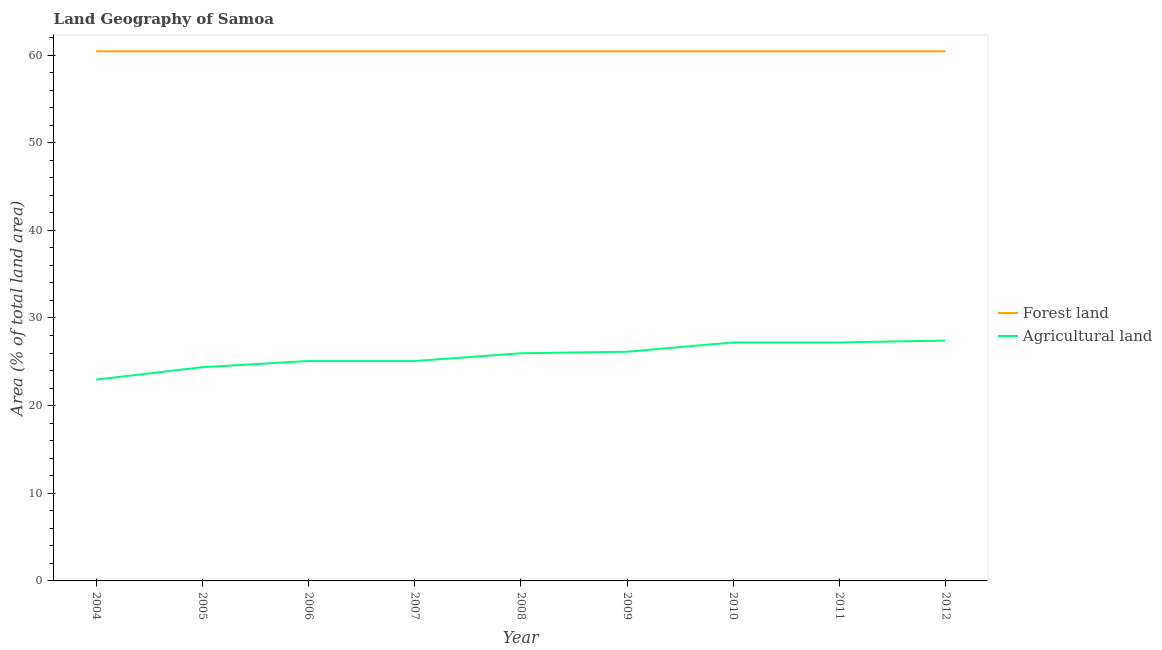How many different coloured lines are there?
Keep it short and to the point. 2. Is the number of lines equal to the number of legend labels?
Offer a terse response. Yes. What is the percentage of land area under agriculture in 2006?
Make the answer very short. 25.09. Across all years, what is the maximum percentage of land area under agriculture?
Offer a very short reply. 27.42. Across all years, what is the minimum percentage of land area under forests?
Offer a very short reply. 60.42. In which year was the percentage of land area under agriculture maximum?
Keep it short and to the point. 2012. What is the total percentage of land area under agriculture in the graph?
Provide a succinct answer. 231.48. What is the difference between the percentage of land area under forests in 2007 and that in 2008?
Ensure brevity in your answer.  0. What is the difference between the percentage of land area under agriculture in 2004 and the percentage of land area under forests in 2012?
Keep it short and to the point. -37.46. What is the average percentage of land area under forests per year?
Offer a terse response. 60.42. In the year 2009, what is the difference between the percentage of land area under agriculture and percentage of land area under forests?
Ensure brevity in your answer.  -34.28. What is the difference between the highest and the second highest percentage of land area under agriculture?
Your answer should be compact. 0.21. What is the difference between the highest and the lowest percentage of land area under agriculture?
Keep it short and to the point. 4.45. Is the sum of the percentage of land area under forests in 2007 and 2009 greater than the maximum percentage of land area under agriculture across all years?
Provide a short and direct response. Yes. Does the percentage of land area under forests monotonically increase over the years?
Provide a succinct answer. No. Is the percentage of land area under forests strictly greater than the percentage of land area under agriculture over the years?
Ensure brevity in your answer.  Yes. Is the percentage of land area under forests strictly less than the percentage of land area under agriculture over the years?
Offer a terse response. No. How many years are there in the graph?
Keep it short and to the point. 9. How are the legend labels stacked?
Give a very brief answer. Vertical. What is the title of the graph?
Your response must be concise. Land Geography of Samoa. What is the label or title of the X-axis?
Ensure brevity in your answer.  Year. What is the label or title of the Y-axis?
Provide a short and direct response. Area (% of total land area). What is the Area (% of total land area) of Forest land in 2004?
Keep it short and to the point. 60.42. What is the Area (% of total land area) in Agricultural land in 2004?
Provide a short and direct response. 22.97. What is the Area (% of total land area) of Forest land in 2005?
Your answer should be compact. 60.42. What is the Area (% of total land area) of Agricultural land in 2005?
Provide a short and direct response. 24.38. What is the Area (% of total land area) of Forest land in 2006?
Your response must be concise. 60.42. What is the Area (% of total land area) of Agricultural land in 2006?
Give a very brief answer. 25.09. What is the Area (% of total land area) of Forest land in 2007?
Make the answer very short. 60.42. What is the Area (% of total land area) in Agricultural land in 2007?
Give a very brief answer. 25.09. What is the Area (% of total land area) of Forest land in 2008?
Give a very brief answer. 60.42. What is the Area (% of total land area) of Agricultural land in 2008?
Provide a succinct answer. 25.97. What is the Area (% of total land area) in Forest land in 2009?
Your answer should be compact. 60.42. What is the Area (% of total land area) of Agricultural land in 2009?
Keep it short and to the point. 26.15. What is the Area (% of total land area) in Forest land in 2010?
Offer a terse response. 60.42. What is the Area (% of total land area) of Agricultural land in 2010?
Keep it short and to the point. 27.21. What is the Area (% of total land area) of Forest land in 2011?
Provide a succinct answer. 60.42. What is the Area (% of total land area) in Agricultural land in 2011?
Make the answer very short. 27.21. What is the Area (% of total land area) of Forest land in 2012?
Your answer should be compact. 60.42. What is the Area (% of total land area) of Agricultural land in 2012?
Provide a short and direct response. 27.42. Across all years, what is the maximum Area (% of total land area) of Forest land?
Keep it short and to the point. 60.42. Across all years, what is the maximum Area (% of total land area) in Agricultural land?
Make the answer very short. 27.42. Across all years, what is the minimum Area (% of total land area) of Forest land?
Your answer should be very brief. 60.42. Across all years, what is the minimum Area (% of total land area) in Agricultural land?
Keep it short and to the point. 22.97. What is the total Area (% of total land area) in Forest land in the graph?
Your answer should be compact. 543.82. What is the total Area (% of total land area) of Agricultural land in the graph?
Ensure brevity in your answer.  231.48. What is the difference between the Area (% of total land area) of Forest land in 2004 and that in 2005?
Provide a succinct answer. 0. What is the difference between the Area (% of total land area) of Agricultural land in 2004 and that in 2005?
Your answer should be very brief. -1.41. What is the difference between the Area (% of total land area) in Agricultural land in 2004 and that in 2006?
Keep it short and to the point. -2.12. What is the difference between the Area (% of total land area) in Agricultural land in 2004 and that in 2007?
Ensure brevity in your answer.  -2.12. What is the difference between the Area (% of total land area) of Agricultural land in 2004 and that in 2008?
Provide a short and direct response. -3. What is the difference between the Area (% of total land area) in Agricultural land in 2004 and that in 2009?
Your answer should be compact. -3.18. What is the difference between the Area (% of total land area) of Agricultural land in 2004 and that in 2010?
Offer a very short reply. -4.24. What is the difference between the Area (% of total land area) in Forest land in 2004 and that in 2011?
Give a very brief answer. 0. What is the difference between the Area (% of total land area) in Agricultural land in 2004 and that in 2011?
Your answer should be very brief. -4.24. What is the difference between the Area (% of total land area) of Forest land in 2004 and that in 2012?
Your answer should be compact. 0. What is the difference between the Area (% of total land area) of Agricultural land in 2004 and that in 2012?
Your answer should be compact. -4.45. What is the difference between the Area (% of total land area) of Agricultural land in 2005 and that in 2006?
Provide a short and direct response. -0.71. What is the difference between the Area (% of total land area) of Forest land in 2005 and that in 2007?
Your response must be concise. 0. What is the difference between the Area (% of total land area) in Agricultural land in 2005 and that in 2007?
Keep it short and to the point. -0.71. What is the difference between the Area (% of total land area) of Forest land in 2005 and that in 2008?
Ensure brevity in your answer.  0. What is the difference between the Area (% of total land area) of Agricultural land in 2005 and that in 2008?
Offer a very short reply. -1.59. What is the difference between the Area (% of total land area) in Forest land in 2005 and that in 2009?
Make the answer very short. 0. What is the difference between the Area (% of total land area) in Agricultural land in 2005 and that in 2009?
Offer a very short reply. -1.77. What is the difference between the Area (% of total land area) of Forest land in 2005 and that in 2010?
Your response must be concise. 0. What is the difference between the Area (% of total land area) in Agricultural land in 2005 and that in 2010?
Provide a short and direct response. -2.83. What is the difference between the Area (% of total land area) of Forest land in 2005 and that in 2011?
Your answer should be compact. 0. What is the difference between the Area (% of total land area) in Agricultural land in 2005 and that in 2011?
Your answer should be very brief. -2.83. What is the difference between the Area (% of total land area) in Forest land in 2005 and that in 2012?
Ensure brevity in your answer.  0. What is the difference between the Area (% of total land area) in Agricultural land in 2005 and that in 2012?
Provide a succinct answer. -3.04. What is the difference between the Area (% of total land area) of Forest land in 2006 and that in 2007?
Provide a short and direct response. 0. What is the difference between the Area (% of total land area) in Forest land in 2006 and that in 2008?
Offer a very short reply. 0. What is the difference between the Area (% of total land area) in Agricultural land in 2006 and that in 2008?
Make the answer very short. -0.88. What is the difference between the Area (% of total land area) in Agricultural land in 2006 and that in 2009?
Offer a very short reply. -1.06. What is the difference between the Area (% of total land area) in Agricultural land in 2006 and that in 2010?
Keep it short and to the point. -2.12. What is the difference between the Area (% of total land area) of Forest land in 2006 and that in 2011?
Your answer should be compact. 0. What is the difference between the Area (% of total land area) in Agricultural land in 2006 and that in 2011?
Your answer should be compact. -2.12. What is the difference between the Area (% of total land area) of Agricultural land in 2006 and that in 2012?
Your answer should be compact. -2.33. What is the difference between the Area (% of total land area) in Forest land in 2007 and that in 2008?
Ensure brevity in your answer.  0. What is the difference between the Area (% of total land area) in Agricultural land in 2007 and that in 2008?
Your answer should be very brief. -0.88. What is the difference between the Area (% of total land area) in Agricultural land in 2007 and that in 2009?
Your response must be concise. -1.06. What is the difference between the Area (% of total land area) in Agricultural land in 2007 and that in 2010?
Keep it short and to the point. -2.12. What is the difference between the Area (% of total land area) of Forest land in 2007 and that in 2011?
Your response must be concise. 0. What is the difference between the Area (% of total land area) of Agricultural land in 2007 and that in 2011?
Keep it short and to the point. -2.12. What is the difference between the Area (% of total land area) in Forest land in 2007 and that in 2012?
Provide a short and direct response. 0. What is the difference between the Area (% of total land area) in Agricultural land in 2007 and that in 2012?
Keep it short and to the point. -2.33. What is the difference between the Area (% of total land area) of Agricultural land in 2008 and that in 2009?
Keep it short and to the point. -0.18. What is the difference between the Area (% of total land area) in Agricultural land in 2008 and that in 2010?
Give a very brief answer. -1.24. What is the difference between the Area (% of total land area) of Agricultural land in 2008 and that in 2011?
Provide a short and direct response. -1.24. What is the difference between the Area (% of total land area) of Agricultural land in 2008 and that in 2012?
Offer a very short reply. -1.45. What is the difference between the Area (% of total land area) in Agricultural land in 2009 and that in 2010?
Your answer should be compact. -1.06. What is the difference between the Area (% of total land area) in Agricultural land in 2009 and that in 2011?
Your answer should be very brief. -1.06. What is the difference between the Area (% of total land area) in Forest land in 2009 and that in 2012?
Your answer should be compact. 0. What is the difference between the Area (% of total land area) in Agricultural land in 2009 and that in 2012?
Offer a terse response. -1.27. What is the difference between the Area (% of total land area) of Forest land in 2010 and that in 2011?
Keep it short and to the point. 0. What is the difference between the Area (% of total land area) of Agricultural land in 2010 and that in 2011?
Make the answer very short. 0. What is the difference between the Area (% of total land area) in Forest land in 2010 and that in 2012?
Give a very brief answer. 0. What is the difference between the Area (% of total land area) of Agricultural land in 2010 and that in 2012?
Provide a succinct answer. -0.21. What is the difference between the Area (% of total land area) of Forest land in 2011 and that in 2012?
Make the answer very short. 0. What is the difference between the Area (% of total land area) of Agricultural land in 2011 and that in 2012?
Provide a short and direct response. -0.21. What is the difference between the Area (% of total land area) in Forest land in 2004 and the Area (% of total land area) in Agricultural land in 2005?
Make the answer very short. 36.04. What is the difference between the Area (% of total land area) in Forest land in 2004 and the Area (% of total land area) in Agricultural land in 2006?
Offer a very short reply. 35.34. What is the difference between the Area (% of total land area) of Forest land in 2004 and the Area (% of total land area) of Agricultural land in 2007?
Make the answer very short. 35.34. What is the difference between the Area (% of total land area) of Forest land in 2004 and the Area (% of total land area) of Agricultural land in 2008?
Keep it short and to the point. 34.45. What is the difference between the Area (% of total land area) in Forest land in 2004 and the Area (% of total land area) in Agricultural land in 2009?
Your answer should be very brief. 34.28. What is the difference between the Area (% of total land area) in Forest land in 2004 and the Area (% of total land area) in Agricultural land in 2010?
Offer a very short reply. 33.22. What is the difference between the Area (% of total land area) of Forest land in 2004 and the Area (% of total land area) of Agricultural land in 2011?
Make the answer very short. 33.22. What is the difference between the Area (% of total land area) in Forest land in 2004 and the Area (% of total land area) in Agricultural land in 2012?
Your response must be concise. 33. What is the difference between the Area (% of total land area) in Forest land in 2005 and the Area (% of total land area) in Agricultural land in 2006?
Your response must be concise. 35.34. What is the difference between the Area (% of total land area) in Forest land in 2005 and the Area (% of total land area) in Agricultural land in 2007?
Your answer should be very brief. 35.34. What is the difference between the Area (% of total land area) of Forest land in 2005 and the Area (% of total land area) of Agricultural land in 2008?
Your answer should be compact. 34.45. What is the difference between the Area (% of total land area) in Forest land in 2005 and the Area (% of total land area) in Agricultural land in 2009?
Ensure brevity in your answer.  34.28. What is the difference between the Area (% of total land area) in Forest land in 2005 and the Area (% of total land area) in Agricultural land in 2010?
Make the answer very short. 33.22. What is the difference between the Area (% of total land area) in Forest land in 2005 and the Area (% of total land area) in Agricultural land in 2011?
Keep it short and to the point. 33.22. What is the difference between the Area (% of total land area) in Forest land in 2005 and the Area (% of total land area) in Agricultural land in 2012?
Make the answer very short. 33. What is the difference between the Area (% of total land area) of Forest land in 2006 and the Area (% of total land area) of Agricultural land in 2007?
Give a very brief answer. 35.34. What is the difference between the Area (% of total land area) of Forest land in 2006 and the Area (% of total land area) of Agricultural land in 2008?
Offer a very short reply. 34.45. What is the difference between the Area (% of total land area) in Forest land in 2006 and the Area (% of total land area) in Agricultural land in 2009?
Provide a short and direct response. 34.28. What is the difference between the Area (% of total land area) of Forest land in 2006 and the Area (% of total land area) of Agricultural land in 2010?
Make the answer very short. 33.22. What is the difference between the Area (% of total land area) of Forest land in 2006 and the Area (% of total land area) of Agricultural land in 2011?
Provide a succinct answer. 33.22. What is the difference between the Area (% of total land area) of Forest land in 2006 and the Area (% of total land area) of Agricultural land in 2012?
Ensure brevity in your answer.  33. What is the difference between the Area (% of total land area) in Forest land in 2007 and the Area (% of total land area) in Agricultural land in 2008?
Ensure brevity in your answer.  34.45. What is the difference between the Area (% of total land area) of Forest land in 2007 and the Area (% of total land area) of Agricultural land in 2009?
Offer a very short reply. 34.28. What is the difference between the Area (% of total land area) of Forest land in 2007 and the Area (% of total land area) of Agricultural land in 2010?
Your response must be concise. 33.22. What is the difference between the Area (% of total land area) in Forest land in 2007 and the Area (% of total land area) in Agricultural land in 2011?
Your response must be concise. 33.22. What is the difference between the Area (% of total land area) in Forest land in 2007 and the Area (% of total land area) in Agricultural land in 2012?
Ensure brevity in your answer.  33. What is the difference between the Area (% of total land area) in Forest land in 2008 and the Area (% of total land area) in Agricultural land in 2009?
Make the answer very short. 34.28. What is the difference between the Area (% of total land area) in Forest land in 2008 and the Area (% of total land area) in Agricultural land in 2010?
Make the answer very short. 33.22. What is the difference between the Area (% of total land area) in Forest land in 2008 and the Area (% of total land area) in Agricultural land in 2011?
Make the answer very short. 33.22. What is the difference between the Area (% of total land area) of Forest land in 2008 and the Area (% of total land area) of Agricultural land in 2012?
Your answer should be compact. 33. What is the difference between the Area (% of total land area) of Forest land in 2009 and the Area (% of total land area) of Agricultural land in 2010?
Give a very brief answer. 33.22. What is the difference between the Area (% of total land area) in Forest land in 2009 and the Area (% of total land area) in Agricultural land in 2011?
Your response must be concise. 33.22. What is the difference between the Area (% of total land area) in Forest land in 2009 and the Area (% of total land area) in Agricultural land in 2012?
Your answer should be compact. 33. What is the difference between the Area (% of total land area) in Forest land in 2010 and the Area (% of total land area) in Agricultural land in 2011?
Your response must be concise. 33.22. What is the difference between the Area (% of total land area) of Forest land in 2010 and the Area (% of total land area) of Agricultural land in 2012?
Make the answer very short. 33. What is the difference between the Area (% of total land area) of Forest land in 2011 and the Area (% of total land area) of Agricultural land in 2012?
Your answer should be very brief. 33. What is the average Area (% of total land area) of Forest land per year?
Offer a terse response. 60.42. What is the average Area (% of total land area) of Agricultural land per year?
Ensure brevity in your answer.  25.72. In the year 2004, what is the difference between the Area (% of total land area) in Forest land and Area (% of total land area) in Agricultural land?
Offer a very short reply. 37.46. In the year 2005, what is the difference between the Area (% of total land area) of Forest land and Area (% of total land area) of Agricultural land?
Your answer should be very brief. 36.04. In the year 2006, what is the difference between the Area (% of total land area) of Forest land and Area (% of total land area) of Agricultural land?
Your answer should be compact. 35.34. In the year 2007, what is the difference between the Area (% of total land area) in Forest land and Area (% of total land area) in Agricultural land?
Keep it short and to the point. 35.34. In the year 2008, what is the difference between the Area (% of total land area) in Forest land and Area (% of total land area) in Agricultural land?
Ensure brevity in your answer.  34.45. In the year 2009, what is the difference between the Area (% of total land area) of Forest land and Area (% of total land area) of Agricultural land?
Keep it short and to the point. 34.28. In the year 2010, what is the difference between the Area (% of total land area) in Forest land and Area (% of total land area) in Agricultural land?
Keep it short and to the point. 33.22. In the year 2011, what is the difference between the Area (% of total land area) of Forest land and Area (% of total land area) of Agricultural land?
Ensure brevity in your answer.  33.22. In the year 2012, what is the difference between the Area (% of total land area) in Forest land and Area (% of total land area) in Agricultural land?
Provide a succinct answer. 33. What is the ratio of the Area (% of total land area) of Agricultural land in 2004 to that in 2005?
Offer a very short reply. 0.94. What is the ratio of the Area (% of total land area) of Forest land in 2004 to that in 2006?
Provide a succinct answer. 1. What is the ratio of the Area (% of total land area) of Agricultural land in 2004 to that in 2006?
Your answer should be very brief. 0.92. What is the ratio of the Area (% of total land area) in Forest land in 2004 to that in 2007?
Offer a very short reply. 1. What is the ratio of the Area (% of total land area) of Agricultural land in 2004 to that in 2007?
Your answer should be compact. 0.92. What is the ratio of the Area (% of total land area) of Forest land in 2004 to that in 2008?
Offer a very short reply. 1. What is the ratio of the Area (% of total land area) in Agricultural land in 2004 to that in 2008?
Your response must be concise. 0.88. What is the ratio of the Area (% of total land area) in Forest land in 2004 to that in 2009?
Keep it short and to the point. 1. What is the ratio of the Area (% of total land area) in Agricultural land in 2004 to that in 2009?
Your answer should be compact. 0.88. What is the ratio of the Area (% of total land area) in Forest land in 2004 to that in 2010?
Provide a succinct answer. 1. What is the ratio of the Area (% of total land area) in Agricultural land in 2004 to that in 2010?
Give a very brief answer. 0.84. What is the ratio of the Area (% of total land area) in Agricultural land in 2004 to that in 2011?
Keep it short and to the point. 0.84. What is the ratio of the Area (% of total land area) in Agricultural land in 2004 to that in 2012?
Your response must be concise. 0.84. What is the ratio of the Area (% of total land area) in Agricultural land in 2005 to that in 2006?
Provide a short and direct response. 0.97. What is the ratio of the Area (% of total land area) of Agricultural land in 2005 to that in 2007?
Provide a short and direct response. 0.97. What is the ratio of the Area (% of total land area) in Forest land in 2005 to that in 2008?
Give a very brief answer. 1. What is the ratio of the Area (% of total land area) in Agricultural land in 2005 to that in 2008?
Offer a very short reply. 0.94. What is the ratio of the Area (% of total land area) of Forest land in 2005 to that in 2009?
Provide a succinct answer. 1. What is the ratio of the Area (% of total land area) of Agricultural land in 2005 to that in 2009?
Offer a terse response. 0.93. What is the ratio of the Area (% of total land area) of Forest land in 2005 to that in 2010?
Provide a succinct answer. 1. What is the ratio of the Area (% of total land area) in Agricultural land in 2005 to that in 2010?
Keep it short and to the point. 0.9. What is the ratio of the Area (% of total land area) of Agricultural land in 2005 to that in 2011?
Offer a very short reply. 0.9. What is the ratio of the Area (% of total land area) of Forest land in 2005 to that in 2012?
Ensure brevity in your answer.  1. What is the ratio of the Area (% of total land area) of Agricultural land in 2005 to that in 2012?
Give a very brief answer. 0.89. What is the ratio of the Area (% of total land area) of Forest land in 2006 to that in 2007?
Make the answer very short. 1. What is the ratio of the Area (% of total land area) of Agricultural land in 2006 to that in 2009?
Make the answer very short. 0.96. What is the ratio of the Area (% of total land area) of Agricultural land in 2006 to that in 2010?
Offer a very short reply. 0.92. What is the ratio of the Area (% of total land area) of Forest land in 2006 to that in 2011?
Make the answer very short. 1. What is the ratio of the Area (% of total land area) in Agricultural land in 2006 to that in 2011?
Keep it short and to the point. 0.92. What is the ratio of the Area (% of total land area) in Agricultural land in 2006 to that in 2012?
Your answer should be compact. 0.91. What is the ratio of the Area (% of total land area) in Forest land in 2007 to that in 2009?
Provide a short and direct response. 1. What is the ratio of the Area (% of total land area) in Agricultural land in 2007 to that in 2009?
Your response must be concise. 0.96. What is the ratio of the Area (% of total land area) in Forest land in 2007 to that in 2010?
Your answer should be very brief. 1. What is the ratio of the Area (% of total land area) in Agricultural land in 2007 to that in 2010?
Your response must be concise. 0.92. What is the ratio of the Area (% of total land area) of Agricultural land in 2007 to that in 2011?
Ensure brevity in your answer.  0.92. What is the ratio of the Area (% of total land area) in Agricultural land in 2007 to that in 2012?
Ensure brevity in your answer.  0.91. What is the ratio of the Area (% of total land area) of Forest land in 2008 to that in 2009?
Keep it short and to the point. 1. What is the ratio of the Area (% of total land area) of Forest land in 2008 to that in 2010?
Offer a very short reply. 1. What is the ratio of the Area (% of total land area) in Agricultural land in 2008 to that in 2010?
Provide a short and direct response. 0.95. What is the ratio of the Area (% of total land area) of Forest land in 2008 to that in 2011?
Offer a very short reply. 1. What is the ratio of the Area (% of total land area) in Agricultural land in 2008 to that in 2011?
Your response must be concise. 0.95. What is the ratio of the Area (% of total land area) in Agricultural land in 2008 to that in 2012?
Ensure brevity in your answer.  0.95. What is the ratio of the Area (% of total land area) in Forest land in 2009 to that in 2010?
Give a very brief answer. 1. What is the ratio of the Area (% of total land area) of Agricultural land in 2009 to that in 2011?
Ensure brevity in your answer.  0.96. What is the ratio of the Area (% of total land area) of Forest land in 2009 to that in 2012?
Keep it short and to the point. 1. What is the ratio of the Area (% of total land area) in Agricultural land in 2009 to that in 2012?
Provide a succinct answer. 0.95. What is the ratio of the Area (% of total land area) of Forest land in 2010 to that in 2012?
Make the answer very short. 1. What is the ratio of the Area (% of total land area) of Forest land in 2011 to that in 2012?
Provide a succinct answer. 1. What is the difference between the highest and the second highest Area (% of total land area) of Agricultural land?
Keep it short and to the point. 0.21. What is the difference between the highest and the lowest Area (% of total land area) of Forest land?
Offer a terse response. 0. What is the difference between the highest and the lowest Area (% of total land area) of Agricultural land?
Keep it short and to the point. 4.45. 